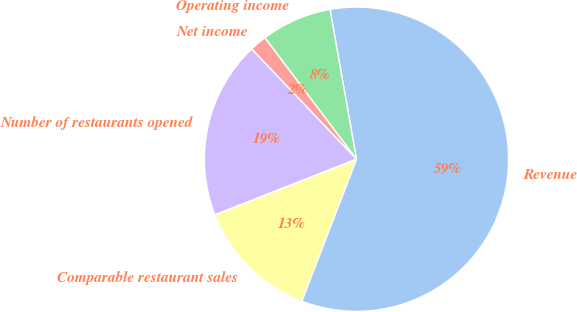<chart> <loc_0><loc_0><loc_500><loc_500><pie_chart><fcel>Revenue<fcel>Operating income<fcel>Net income<fcel>Number of restaurants opened<fcel>Comparable restaurant sales<nl><fcel>58.64%<fcel>7.5%<fcel>1.82%<fcel>18.86%<fcel>13.18%<nl></chart> 